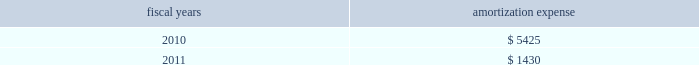Intangible assets are amortized on a straight-line basis over their estimated useful lives or on an accelerated method of amortization that is expected to reflect the estimated pattern of economic use .
The remaining amortization expense will be recognized over a weighted-average period of approximately 0.9 years .
Amortization expense from continuing operations , related to intangibles was $ 7.4 million , $ 9.3 million and $ 9.2 million in fiscal 2009 , 2008 and 2007 , respectively .
The company expects annual amortization expense for these intangible assets to be: .
Grant accounting certain of the company 2019s foreign subsidiaries have received various grants from governmental agencies .
These grants include capital , employment and research and development grants .
Capital grants for the acquisition of property and equipment are netted against the related capital expenditures and amortized as a credit to depreciation expense over the useful life of the related asset .
Employment grants , which relate to employee hiring and training , and research and development grants are recognized in earnings in the period in which the related expenditures are incurred by the company .
Translation of foreign currencies the functional currency for the company 2019s foreign sales and research and development operations is the applicable local currency .
Gains and losses resulting from translation of these foreign currencies into u.s .
Dollars are recorded in accumulated other comprehensive ( loss ) income .
Transaction gains and losses and remeasurement of foreign currency denominated assets and liabilities are included in income currently , including those at the company 2019s principal foreign manufacturing operations where the functional currency is the u.s .
Dollar .
Foreign currency transaction gains or losses included in other expenses , net , were not material in fiscal 2009 , 2008 or 2007 .
Derivative instruments and hedging agreements foreign exchange exposure management 2014 the company enters into forward foreign currency exchange contracts to offset certain operational and balance sheet exposures from the impact of changes in foreign currency exchange rates .
Such exposures result from the portion of the company 2019s operations , assets and liabilities that are denominated in currencies other than the u.s .
Dollar , primarily the euro ; other exposures include the philippine peso and the british pound .
These foreign currency exchange contracts are entered into to support transactions made in the normal course of business , and accordingly , are not speculative in nature .
The contracts are for periods consistent with the terms of the underlying transactions , generally one year or less .
Hedges related to anticipated transactions are designated and documented at the inception of the respective hedges as cash flow hedges and are evaluated for effectiveness monthly .
Derivative instruments are employed to eliminate or minimize certain foreign currency exposures that can be confidently identified and quantified .
As the terms of the contract and the underlying transaction are matched at inception , forward contract effectiveness is calculated by comparing the change in fair value of the contract to the change in the forward value of the anticipated transaction , with the effective portion of the gain or loss on the derivative instrument reported as a component of accumulated other comprehensive ( loss ) income ( oci ) in shareholders 2019 equity and reclassified into earnings in the same period during which the hedged transaction affects earnings .
Any residual change in fair value of the instruments , or ineffectiveness , is recognized immediately in other income/expense .
Additionally , the company enters into forward foreign currency contracts that economically hedge the gains and losses generated by the remeasurement of certain recorded assets and liabilities in a non-functional currency .
Changes in the fair value of these undesignated hedges are recognized in other income/expense immediately as an offset to the changes in the fair value of the asset or liability being hedged .
Analog devices , inc .
Notes to consolidated financial statements 2014 ( continued ) .
What is the expected growth rate in amortization expense in 2010? 
Computations: (((5425 / 1000) - 7.4) / 7.4)
Answer: -0.26689. 